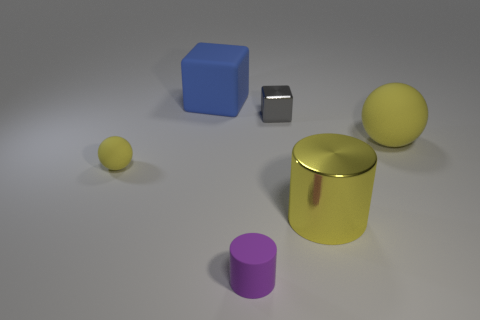What time of day does the lighting in the image suggest? The soft shadows and neutral tones suggest the image is lit with a diffuse light source, making it difficult to infer a specific time of day. It appears to be more indicative of studio lighting than natural sunlight. 